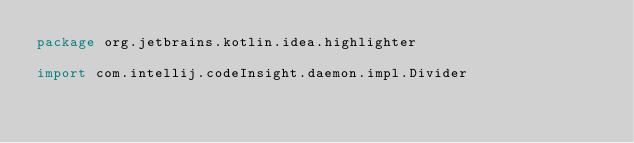Convert code to text. <code><loc_0><loc_0><loc_500><loc_500><_Kotlin_>package org.jetbrains.kotlin.idea.highlighter

import com.intellij.codeInsight.daemon.impl.Divider</code> 